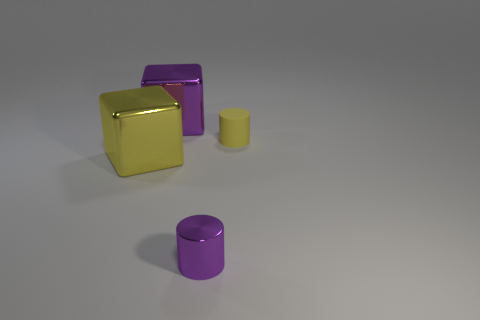Are there any other things that are the same material as the small yellow cylinder?
Provide a short and direct response. No. The tiny matte thing has what shape?
Offer a very short reply. Cylinder. What is the size of the other thing that is the same color as the tiny rubber thing?
Give a very brief answer. Large. What size is the cube that is in front of the cube that is on the right side of the yellow metallic object?
Offer a very short reply. Large. There is a yellow thing that is behind the yellow block; what size is it?
Make the answer very short. Small. Is the number of tiny rubber cylinders that are in front of the tiny metal thing less than the number of big objects that are on the left side of the large purple object?
Make the answer very short. Yes. What is the color of the matte object?
Ensure brevity in your answer.  Yellow. Is there a tiny thing of the same color as the small shiny cylinder?
Your response must be concise. No. What is the shape of the object that is in front of the yellow object left of the big cube behind the yellow matte thing?
Your answer should be compact. Cylinder. There is a yellow object on the right side of the small purple cylinder; what material is it?
Give a very brief answer. Rubber. 